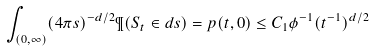<formula> <loc_0><loc_0><loc_500><loc_500>\int _ { ( 0 , \infty ) } ( 4 \pi s ) ^ { - d / 2 } \P ( S _ { t } \in d s ) = p ( t , 0 ) \leq C _ { 1 } \phi ^ { - 1 } ( t ^ { - 1 } ) ^ { d / 2 }</formula> 